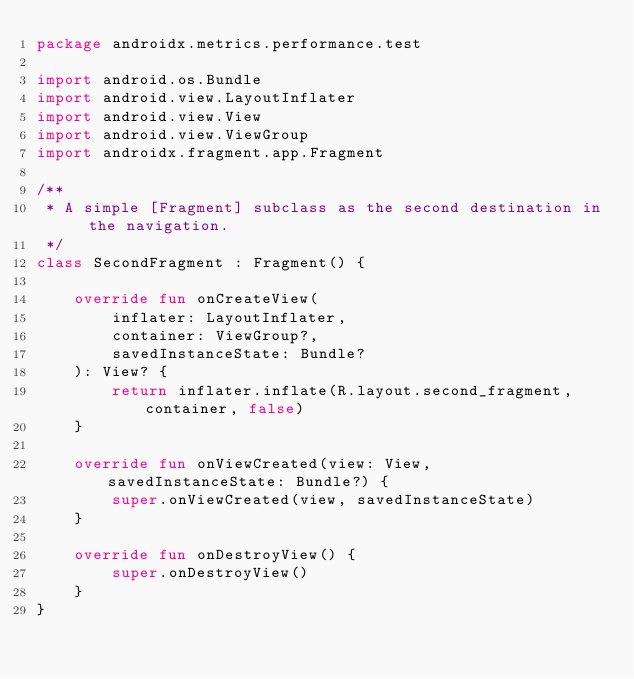Convert code to text. <code><loc_0><loc_0><loc_500><loc_500><_Kotlin_>package androidx.metrics.performance.test

import android.os.Bundle
import android.view.LayoutInflater
import android.view.View
import android.view.ViewGroup
import androidx.fragment.app.Fragment

/**
 * A simple [Fragment] subclass as the second destination in the navigation.
 */
class SecondFragment : Fragment() {

    override fun onCreateView(
        inflater: LayoutInflater,
        container: ViewGroup?,
        savedInstanceState: Bundle?
    ): View? {
        return inflater.inflate(R.layout.second_fragment, container, false)
    }

    override fun onViewCreated(view: View, savedInstanceState: Bundle?) {
        super.onViewCreated(view, savedInstanceState)
    }

    override fun onDestroyView() {
        super.onDestroyView()
    }
}</code> 